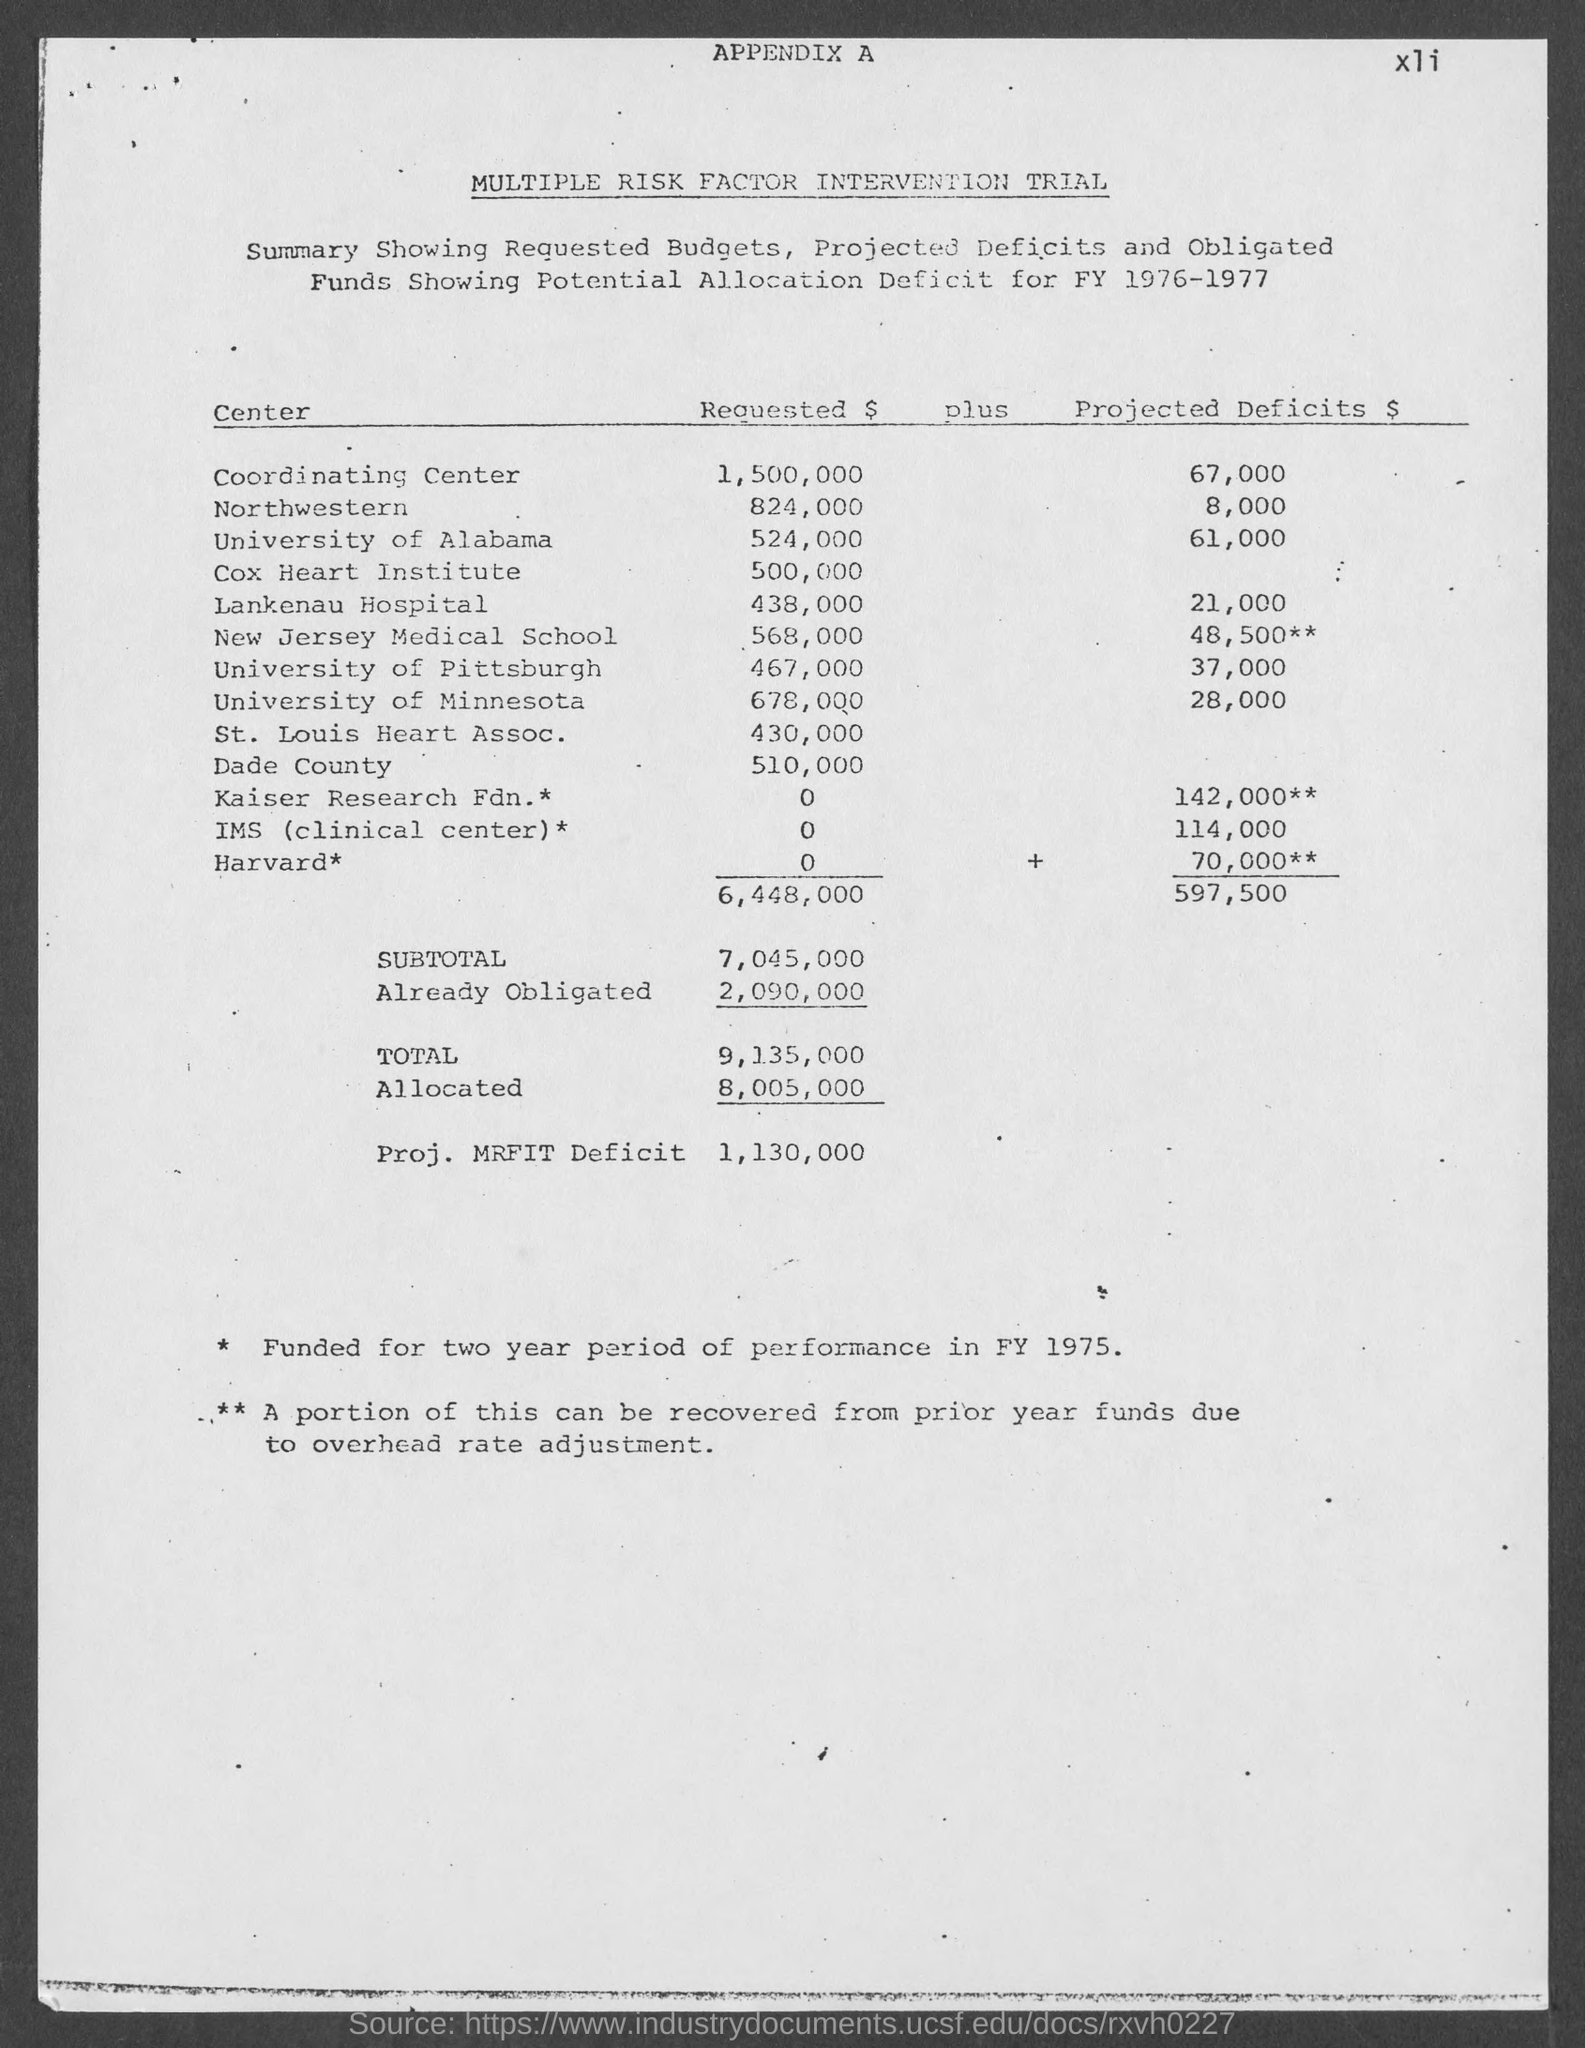What is the projected deficits $ for  coordinating center ?
Make the answer very short. $ 67,000. What is the projected deficits $ for northwestern center ?
Your answer should be compact. $8,000. What is the projected deficits $ for university of alabama ?
Give a very brief answer. $61,000. What is the projected deficits $ for lankenau hospital ?
Your answer should be compact. 21,000. What is the projected deficits $ for new jersey medical school?
Your answer should be compact. $48,500. What is the projected deficits $ for university of pittsburgh ?
Give a very brief answer. $37,000. What is the projected deficits $ for university of minnesota?
Your answer should be compact. 28,000. What is the projected deficits $ for kaiser research fdn.* ?
Offer a very short reply. $142,000. What is the projected deficits $ for ims ( clinical center) ?
Provide a short and direct response. $114,000. What is the projected deficits $ for harvard* ?
Offer a terse response. $70,000**. 